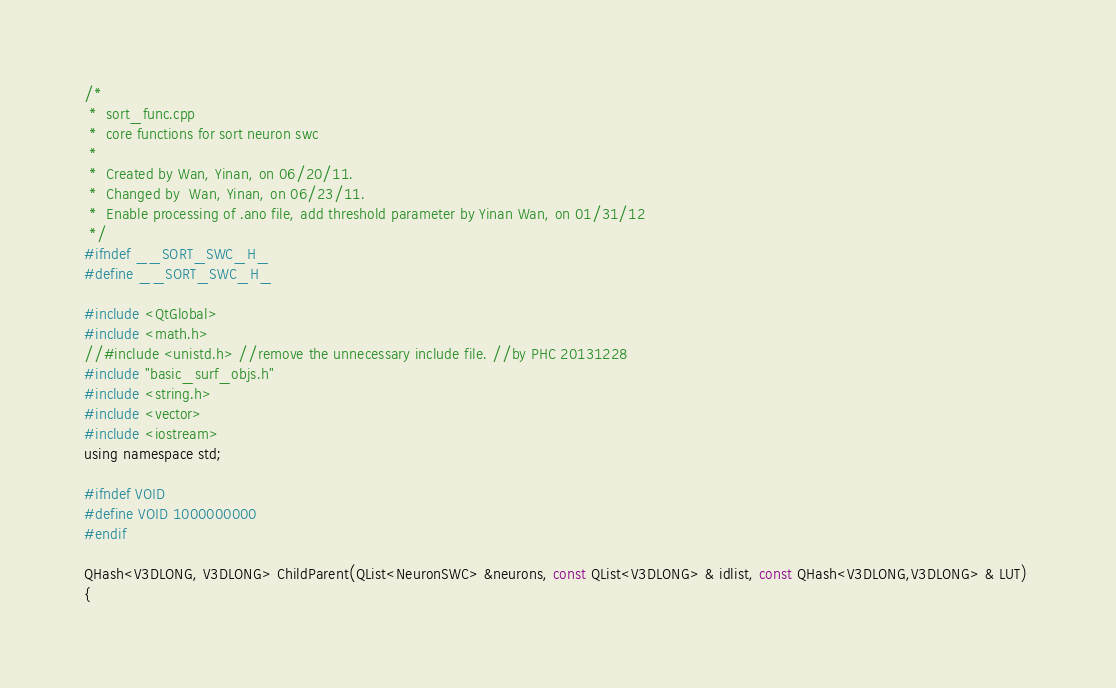<code> <loc_0><loc_0><loc_500><loc_500><_C_>/*
 *  sort_func.cpp
 *  core functions for sort neuron swc 
 *
 *  Created by Wan, Yinan, on 06/20/11.
 *  Changed by  Wan, Yinan, on 06/23/11.
 *  Enable processing of .ano file, add threshold parameter by Yinan Wan, on 01/31/12
 */
#ifndef __SORT_SWC_H_
#define __SORT_SWC_H_

#include <QtGlobal>
#include <math.h>
//#include <unistd.h> //remove the unnecessary include file. //by PHC 20131228
#include "basic_surf_objs.h"
#include <string.h>
#include <vector>
#include <iostream>
using namespace std;

#ifndef VOID
#define VOID 1000000000
#endif

QHash<V3DLONG, V3DLONG> ChildParent(QList<NeuronSWC> &neurons, const QList<V3DLONG> & idlist, const QHash<V3DLONG,V3DLONG> & LUT) 
{</code> 